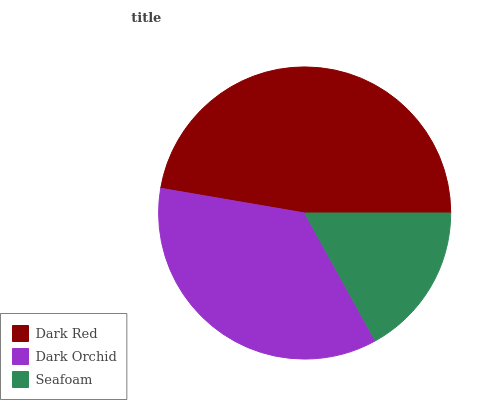Is Seafoam the minimum?
Answer yes or no. Yes. Is Dark Red the maximum?
Answer yes or no. Yes. Is Dark Orchid the minimum?
Answer yes or no. No. Is Dark Orchid the maximum?
Answer yes or no. No. Is Dark Red greater than Dark Orchid?
Answer yes or no. Yes. Is Dark Orchid less than Dark Red?
Answer yes or no. Yes. Is Dark Orchid greater than Dark Red?
Answer yes or no. No. Is Dark Red less than Dark Orchid?
Answer yes or no. No. Is Dark Orchid the high median?
Answer yes or no. Yes. Is Dark Orchid the low median?
Answer yes or no. Yes. Is Dark Red the high median?
Answer yes or no. No. Is Seafoam the low median?
Answer yes or no. No. 